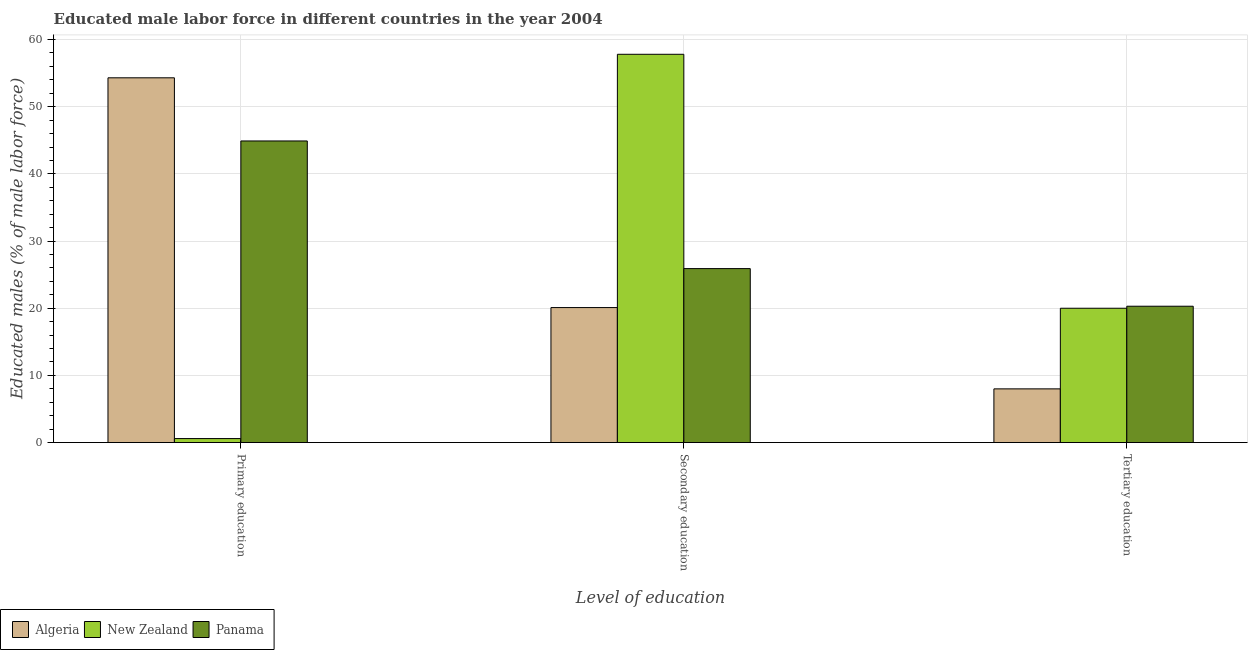How many bars are there on the 3rd tick from the right?
Your response must be concise. 3. What is the label of the 2nd group of bars from the left?
Give a very brief answer. Secondary education. What is the percentage of male labor force who received secondary education in Panama?
Offer a terse response. 25.9. Across all countries, what is the maximum percentage of male labor force who received primary education?
Offer a very short reply. 54.3. Across all countries, what is the minimum percentage of male labor force who received primary education?
Offer a very short reply. 0.6. In which country was the percentage of male labor force who received primary education maximum?
Your response must be concise. Algeria. In which country was the percentage of male labor force who received primary education minimum?
Provide a succinct answer. New Zealand. What is the total percentage of male labor force who received secondary education in the graph?
Make the answer very short. 103.8. What is the difference between the percentage of male labor force who received secondary education in Algeria and that in New Zealand?
Give a very brief answer. -37.7. What is the difference between the percentage of male labor force who received tertiary education in New Zealand and the percentage of male labor force who received secondary education in Panama?
Your response must be concise. -5.9. What is the average percentage of male labor force who received tertiary education per country?
Offer a very short reply. 16.1. What is the difference between the percentage of male labor force who received tertiary education and percentage of male labor force who received primary education in Panama?
Your response must be concise. -24.6. What is the ratio of the percentage of male labor force who received primary education in Panama to that in New Zealand?
Give a very brief answer. 74.83. Is the percentage of male labor force who received primary education in Panama less than that in New Zealand?
Provide a short and direct response. No. Is the difference between the percentage of male labor force who received secondary education in New Zealand and Algeria greater than the difference between the percentage of male labor force who received tertiary education in New Zealand and Algeria?
Your response must be concise. Yes. What is the difference between the highest and the second highest percentage of male labor force who received tertiary education?
Your answer should be very brief. 0.3. What is the difference between the highest and the lowest percentage of male labor force who received primary education?
Provide a succinct answer. 53.7. In how many countries, is the percentage of male labor force who received tertiary education greater than the average percentage of male labor force who received tertiary education taken over all countries?
Provide a succinct answer. 2. Is the sum of the percentage of male labor force who received primary education in New Zealand and Panama greater than the maximum percentage of male labor force who received secondary education across all countries?
Ensure brevity in your answer.  No. What does the 3rd bar from the left in Tertiary education represents?
Your response must be concise. Panama. What does the 1st bar from the right in Tertiary education represents?
Provide a succinct answer. Panama. How many bars are there?
Provide a succinct answer. 9. Are all the bars in the graph horizontal?
Your response must be concise. No. How many countries are there in the graph?
Your answer should be very brief. 3. What is the difference between two consecutive major ticks on the Y-axis?
Your answer should be very brief. 10. Are the values on the major ticks of Y-axis written in scientific E-notation?
Offer a terse response. No. Does the graph contain any zero values?
Your answer should be very brief. No. Does the graph contain grids?
Offer a very short reply. Yes. How many legend labels are there?
Keep it short and to the point. 3. How are the legend labels stacked?
Make the answer very short. Horizontal. What is the title of the graph?
Ensure brevity in your answer.  Educated male labor force in different countries in the year 2004. What is the label or title of the X-axis?
Give a very brief answer. Level of education. What is the label or title of the Y-axis?
Give a very brief answer. Educated males (% of male labor force). What is the Educated males (% of male labor force) of Algeria in Primary education?
Offer a very short reply. 54.3. What is the Educated males (% of male labor force) in New Zealand in Primary education?
Your answer should be very brief. 0.6. What is the Educated males (% of male labor force) in Panama in Primary education?
Your answer should be very brief. 44.9. What is the Educated males (% of male labor force) of Algeria in Secondary education?
Keep it short and to the point. 20.1. What is the Educated males (% of male labor force) in New Zealand in Secondary education?
Ensure brevity in your answer.  57.8. What is the Educated males (% of male labor force) of Panama in Secondary education?
Offer a very short reply. 25.9. What is the Educated males (% of male labor force) in Panama in Tertiary education?
Ensure brevity in your answer.  20.3. Across all Level of education, what is the maximum Educated males (% of male labor force) of Algeria?
Make the answer very short. 54.3. Across all Level of education, what is the maximum Educated males (% of male labor force) of New Zealand?
Keep it short and to the point. 57.8. Across all Level of education, what is the maximum Educated males (% of male labor force) in Panama?
Your answer should be very brief. 44.9. Across all Level of education, what is the minimum Educated males (% of male labor force) of Algeria?
Provide a succinct answer. 8. Across all Level of education, what is the minimum Educated males (% of male labor force) of New Zealand?
Your answer should be very brief. 0.6. Across all Level of education, what is the minimum Educated males (% of male labor force) in Panama?
Keep it short and to the point. 20.3. What is the total Educated males (% of male labor force) in Algeria in the graph?
Ensure brevity in your answer.  82.4. What is the total Educated males (% of male labor force) in New Zealand in the graph?
Ensure brevity in your answer.  78.4. What is the total Educated males (% of male labor force) of Panama in the graph?
Provide a succinct answer. 91.1. What is the difference between the Educated males (% of male labor force) in Algeria in Primary education and that in Secondary education?
Make the answer very short. 34.2. What is the difference between the Educated males (% of male labor force) in New Zealand in Primary education and that in Secondary education?
Offer a very short reply. -57.2. What is the difference between the Educated males (% of male labor force) of Algeria in Primary education and that in Tertiary education?
Your response must be concise. 46.3. What is the difference between the Educated males (% of male labor force) of New Zealand in Primary education and that in Tertiary education?
Offer a terse response. -19.4. What is the difference between the Educated males (% of male labor force) of Panama in Primary education and that in Tertiary education?
Your answer should be very brief. 24.6. What is the difference between the Educated males (% of male labor force) in New Zealand in Secondary education and that in Tertiary education?
Offer a very short reply. 37.8. What is the difference between the Educated males (% of male labor force) in Algeria in Primary education and the Educated males (% of male labor force) in Panama in Secondary education?
Your answer should be compact. 28.4. What is the difference between the Educated males (% of male labor force) of New Zealand in Primary education and the Educated males (% of male labor force) of Panama in Secondary education?
Make the answer very short. -25.3. What is the difference between the Educated males (% of male labor force) of Algeria in Primary education and the Educated males (% of male labor force) of New Zealand in Tertiary education?
Provide a succinct answer. 34.3. What is the difference between the Educated males (% of male labor force) in Algeria in Primary education and the Educated males (% of male labor force) in Panama in Tertiary education?
Provide a short and direct response. 34. What is the difference between the Educated males (% of male labor force) in New Zealand in Primary education and the Educated males (% of male labor force) in Panama in Tertiary education?
Your response must be concise. -19.7. What is the difference between the Educated males (% of male labor force) in New Zealand in Secondary education and the Educated males (% of male labor force) in Panama in Tertiary education?
Make the answer very short. 37.5. What is the average Educated males (% of male labor force) of Algeria per Level of education?
Make the answer very short. 27.47. What is the average Educated males (% of male labor force) in New Zealand per Level of education?
Your answer should be compact. 26.13. What is the average Educated males (% of male labor force) of Panama per Level of education?
Your response must be concise. 30.37. What is the difference between the Educated males (% of male labor force) of Algeria and Educated males (% of male labor force) of New Zealand in Primary education?
Your response must be concise. 53.7. What is the difference between the Educated males (% of male labor force) of Algeria and Educated males (% of male labor force) of Panama in Primary education?
Make the answer very short. 9.4. What is the difference between the Educated males (% of male labor force) in New Zealand and Educated males (% of male labor force) in Panama in Primary education?
Give a very brief answer. -44.3. What is the difference between the Educated males (% of male labor force) of Algeria and Educated males (% of male labor force) of New Zealand in Secondary education?
Make the answer very short. -37.7. What is the difference between the Educated males (% of male labor force) of Algeria and Educated males (% of male labor force) of Panama in Secondary education?
Offer a very short reply. -5.8. What is the difference between the Educated males (% of male labor force) of New Zealand and Educated males (% of male labor force) of Panama in Secondary education?
Your answer should be compact. 31.9. What is the difference between the Educated males (% of male labor force) in Algeria and Educated males (% of male labor force) in New Zealand in Tertiary education?
Keep it short and to the point. -12. What is the difference between the Educated males (% of male labor force) in Algeria and Educated males (% of male labor force) in Panama in Tertiary education?
Keep it short and to the point. -12.3. What is the difference between the Educated males (% of male labor force) in New Zealand and Educated males (% of male labor force) in Panama in Tertiary education?
Ensure brevity in your answer.  -0.3. What is the ratio of the Educated males (% of male labor force) in Algeria in Primary education to that in Secondary education?
Your answer should be very brief. 2.7. What is the ratio of the Educated males (% of male labor force) of New Zealand in Primary education to that in Secondary education?
Ensure brevity in your answer.  0.01. What is the ratio of the Educated males (% of male labor force) of Panama in Primary education to that in Secondary education?
Provide a short and direct response. 1.73. What is the ratio of the Educated males (% of male labor force) in Algeria in Primary education to that in Tertiary education?
Your answer should be very brief. 6.79. What is the ratio of the Educated males (% of male labor force) of New Zealand in Primary education to that in Tertiary education?
Provide a short and direct response. 0.03. What is the ratio of the Educated males (% of male labor force) of Panama in Primary education to that in Tertiary education?
Provide a succinct answer. 2.21. What is the ratio of the Educated males (% of male labor force) in Algeria in Secondary education to that in Tertiary education?
Give a very brief answer. 2.51. What is the ratio of the Educated males (% of male labor force) in New Zealand in Secondary education to that in Tertiary education?
Provide a succinct answer. 2.89. What is the ratio of the Educated males (% of male labor force) of Panama in Secondary education to that in Tertiary education?
Make the answer very short. 1.28. What is the difference between the highest and the second highest Educated males (% of male labor force) in Algeria?
Ensure brevity in your answer.  34.2. What is the difference between the highest and the second highest Educated males (% of male labor force) of New Zealand?
Give a very brief answer. 37.8. What is the difference between the highest and the lowest Educated males (% of male labor force) in Algeria?
Offer a very short reply. 46.3. What is the difference between the highest and the lowest Educated males (% of male labor force) of New Zealand?
Make the answer very short. 57.2. What is the difference between the highest and the lowest Educated males (% of male labor force) of Panama?
Your answer should be compact. 24.6. 